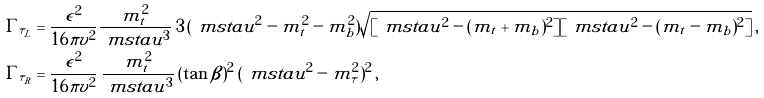<formula> <loc_0><loc_0><loc_500><loc_500>\Gamma _ { \tilde { \tau } _ { L } } & = \frac { \epsilon ^ { 2 } } { 1 6 \pi v ^ { 2 } } \frac { m _ { t } ^ { 2 } } { \ m s t a u ^ { 3 } } \, 3 \, ( \ m s t a u ^ { 2 } - m _ { t } ^ { 2 } - m _ { b } ^ { 2 } ) \sqrt { [ \ m s t a u ^ { 2 } - ( m _ { t } + m _ { b } ) ^ { 2 } ] [ \ m s t a u ^ { 2 } - ( m _ { t } - m _ { b } ) ^ { 2 } ] } \, , \\ \Gamma _ { \tilde { \tau } _ { R } } & = \frac { \epsilon ^ { 2 } } { 1 6 \pi v ^ { 2 } } \, \frac { m _ { t } ^ { 2 } } { \ m s t a u ^ { 3 } } \, ( \tan \beta ) ^ { 2 } \, ( \ m s t a u ^ { 2 } - m _ { \tau } ^ { 2 } ) ^ { 2 } \, ,</formula> 